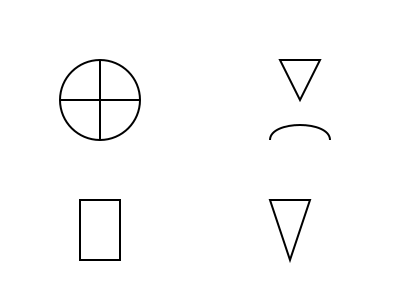As a business owner who values moral teachings, identify the religious symbol that represents Christianity in the diagram. To identify the Christian symbol in the diagram, let's examine each symbol step-by-step:

1. Top-left: A circle with intersecting vertical and horizontal lines. This is the Christian cross, specifically a Greek cross.
2. Top-right: A downward-pointing triangle. This is not typically associated with Christianity.
3. Middle-right: A curved line resembling a smile or arc. This is not a distinct religious symbol.
4. Bottom-left: A rectangle with a smaller rectangle on top. This resembles a simplified Torah scroll, associated with Judaism.
5. Bottom-right: An upward-pointing triangle. This is not typically associated with Christianity.

Among these symbols, the one that clearly represents Christianity is the cross in the top-left corner. The cross is the primary symbol of the Christian faith, representing Jesus Christ's crucifixion and the core beliefs of Christianity.
Answer: The Greek cross (top-left symbol) 